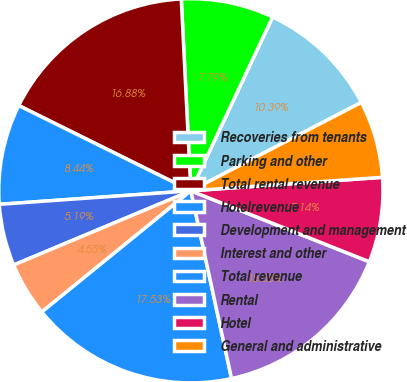Convert chart to OTSL. <chart><loc_0><loc_0><loc_500><loc_500><pie_chart><fcel>Recoveries from tenants<fcel>Parking and other<fcel>Total rental revenue<fcel>Hotelrevenue<fcel>Development and management<fcel>Interest and other<fcel>Total revenue<fcel>Rental<fcel>Hotel<fcel>General and administrative<nl><fcel>10.39%<fcel>7.79%<fcel>16.88%<fcel>8.44%<fcel>5.19%<fcel>4.55%<fcel>17.53%<fcel>15.58%<fcel>7.14%<fcel>6.49%<nl></chart> 